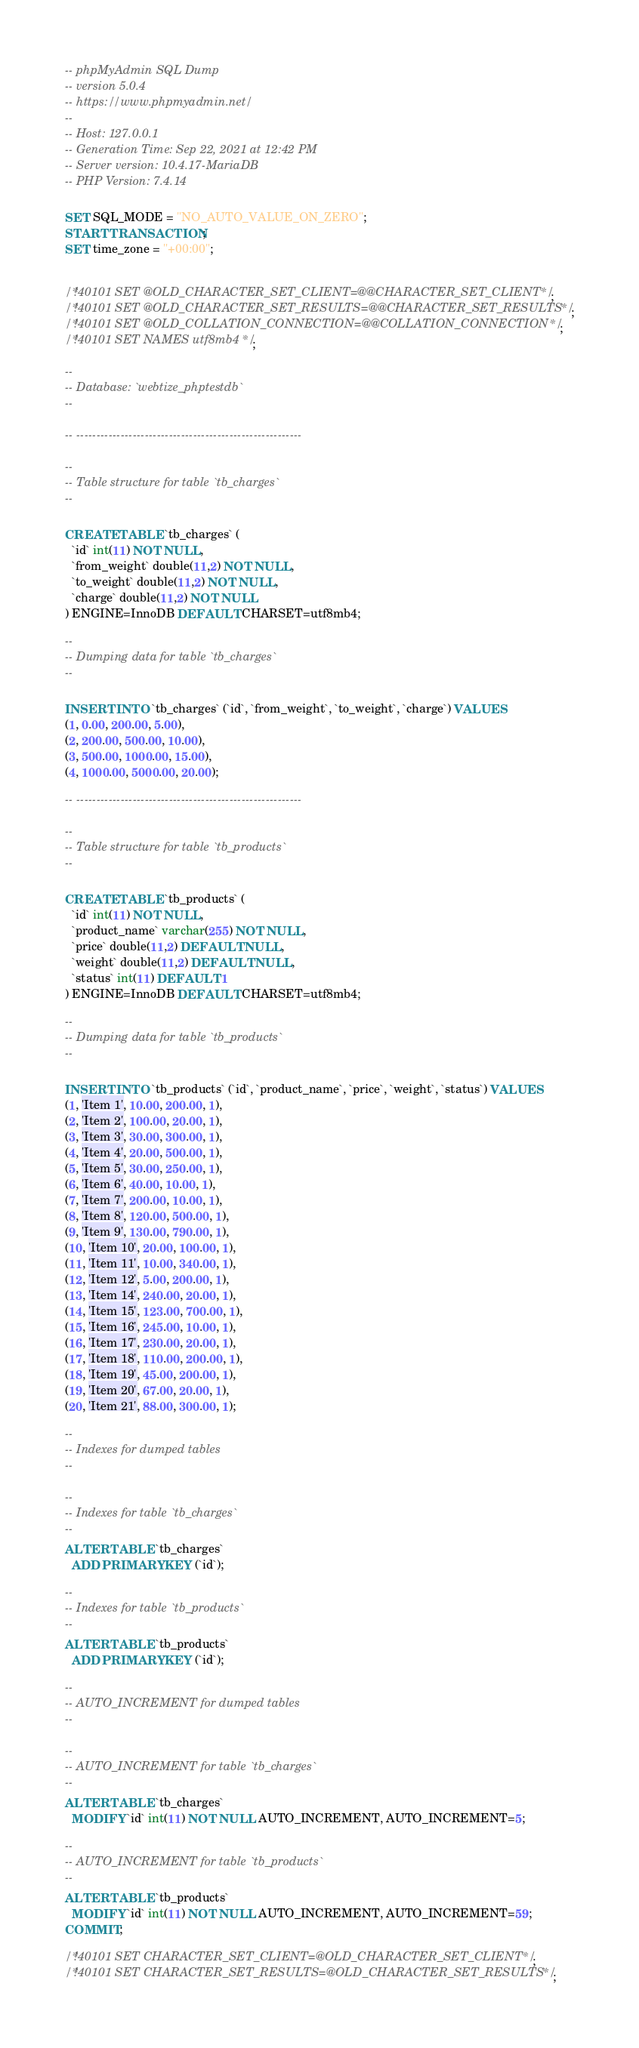Convert code to text. <code><loc_0><loc_0><loc_500><loc_500><_SQL_>-- phpMyAdmin SQL Dump
-- version 5.0.4
-- https://www.phpmyadmin.net/
--
-- Host: 127.0.0.1
-- Generation Time: Sep 22, 2021 at 12:42 PM
-- Server version: 10.4.17-MariaDB
-- PHP Version: 7.4.14

SET SQL_MODE = "NO_AUTO_VALUE_ON_ZERO";
START TRANSACTION;
SET time_zone = "+00:00";


/*!40101 SET @OLD_CHARACTER_SET_CLIENT=@@CHARACTER_SET_CLIENT */;
/*!40101 SET @OLD_CHARACTER_SET_RESULTS=@@CHARACTER_SET_RESULTS */;
/*!40101 SET @OLD_COLLATION_CONNECTION=@@COLLATION_CONNECTION */;
/*!40101 SET NAMES utf8mb4 */;

--
-- Database: `webtize_phptestdb`
--

-- --------------------------------------------------------

--
-- Table structure for table `tb_charges`
--

CREATE TABLE `tb_charges` (
  `id` int(11) NOT NULL,
  `from_weight` double(11,2) NOT NULL,
  `to_weight` double(11,2) NOT NULL,
  `charge` double(11,2) NOT NULL
) ENGINE=InnoDB DEFAULT CHARSET=utf8mb4;

--
-- Dumping data for table `tb_charges`
--

INSERT INTO `tb_charges` (`id`, `from_weight`, `to_weight`, `charge`) VALUES
(1, 0.00, 200.00, 5.00),
(2, 200.00, 500.00, 10.00),
(3, 500.00, 1000.00, 15.00),
(4, 1000.00, 5000.00, 20.00);

-- --------------------------------------------------------

--
-- Table structure for table `tb_products`
--

CREATE TABLE `tb_products` (
  `id` int(11) NOT NULL,
  `product_name` varchar(255) NOT NULL,
  `price` double(11,2) DEFAULT NULL,
  `weight` double(11,2) DEFAULT NULL,
  `status` int(11) DEFAULT 1
) ENGINE=InnoDB DEFAULT CHARSET=utf8mb4;

--
-- Dumping data for table `tb_products`
--

INSERT INTO `tb_products` (`id`, `product_name`, `price`, `weight`, `status`) VALUES
(1, 'Item 1', 10.00, 200.00, 1),
(2, 'Item 2', 100.00, 20.00, 1),
(3, 'Item 3', 30.00, 300.00, 1),
(4, 'Item 4', 20.00, 500.00, 1),
(5, 'Item 5', 30.00, 250.00, 1),
(6, 'Item 6', 40.00, 10.00, 1),
(7, 'Item 7', 200.00, 10.00, 1),
(8, 'Item 8', 120.00, 500.00, 1),
(9, 'Item 9', 130.00, 790.00, 1),
(10, 'Item 10', 20.00, 100.00, 1),
(11, 'Item 11', 10.00, 340.00, 1),
(12, 'Item 12', 5.00, 200.00, 1),
(13, 'Item 14', 240.00, 20.00, 1),
(14, 'Item 15', 123.00, 700.00, 1),
(15, 'Item 16', 245.00, 10.00, 1),
(16, 'Item 17', 230.00, 20.00, 1),
(17, 'Item 18', 110.00, 200.00, 1),
(18, 'Item 19', 45.00, 200.00, 1),
(19, 'Item 20', 67.00, 20.00, 1),
(20, 'Item 21', 88.00, 300.00, 1);

--
-- Indexes for dumped tables
--

--
-- Indexes for table `tb_charges`
--
ALTER TABLE `tb_charges`
  ADD PRIMARY KEY (`id`);

--
-- Indexes for table `tb_products`
--
ALTER TABLE `tb_products`
  ADD PRIMARY KEY (`id`);

--
-- AUTO_INCREMENT for dumped tables
--

--
-- AUTO_INCREMENT for table `tb_charges`
--
ALTER TABLE `tb_charges`
  MODIFY `id` int(11) NOT NULL AUTO_INCREMENT, AUTO_INCREMENT=5;

--
-- AUTO_INCREMENT for table `tb_products`
--
ALTER TABLE `tb_products`
  MODIFY `id` int(11) NOT NULL AUTO_INCREMENT, AUTO_INCREMENT=59;
COMMIT;

/*!40101 SET CHARACTER_SET_CLIENT=@OLD_CHARACTER_SET_CLIENT */;
/*!40101 SET CHARACTER_SET_RESULTS=@OLD_CHARACTER_SET_RESULTS */;</code> 